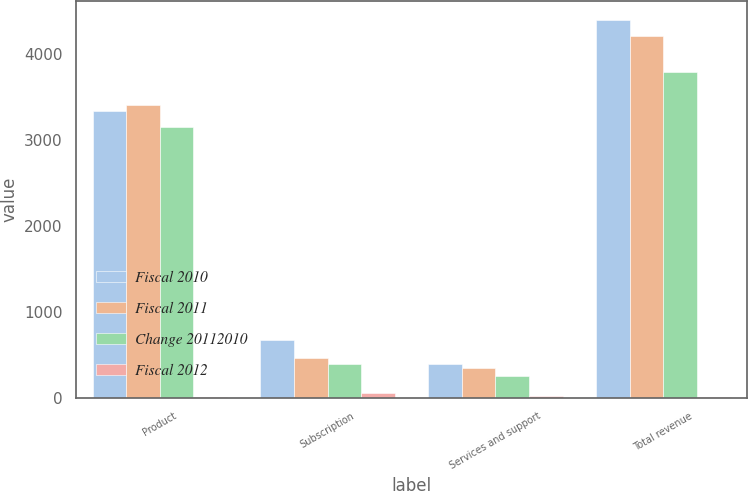Convert chart. <chart><loc_0><loc_0><loc_500><loc_500><stacked_bar_chart><ecel><fcel>Product<fcel>Subscription<fcel>Services and support<fcel>Total revenue<nl><fcel>Fiscal 2010<fcel>3342.8<fcel>673.2<fcel>387.7<fcel>4403.7<nl><fcel>Fiscal 2011<fcel>3416.5<fcel>458.6<fcel>341.2<fcel>4216.3<nl><fcel>Change 20112010<fcel>3159.2<fcel>386.8<fcel>254<fcel>3800<nl><fcel>Fiscal 2012<fcel>2<fcel>47<fcel>14<fcel>4<nl></chart> 